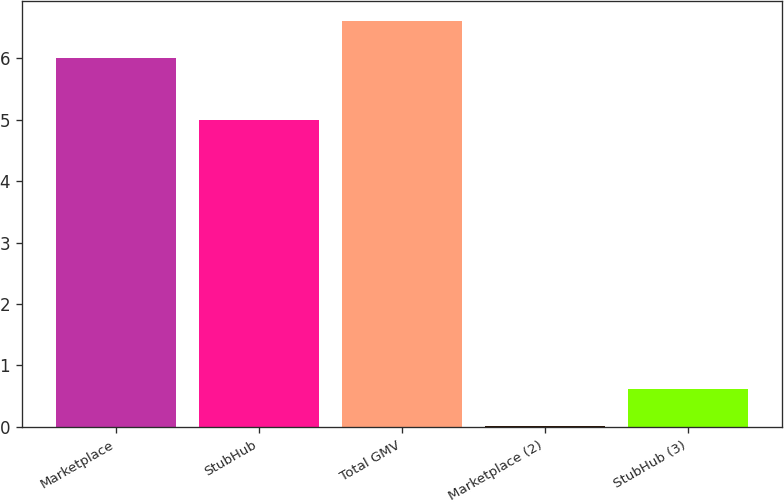Convert chart. <chart><loc_0><loc_0><loc_500><loc_500><bar_chart><fcel>Marketplace<fcel>StubHub<fcel>Total GMV<fcel>Marketplace (2)<fcel>StubHub (3)<nl><fcel>6<fcel>5<fcel>6.6<fcel>0.02<fcel>0.62<nl></chart> 